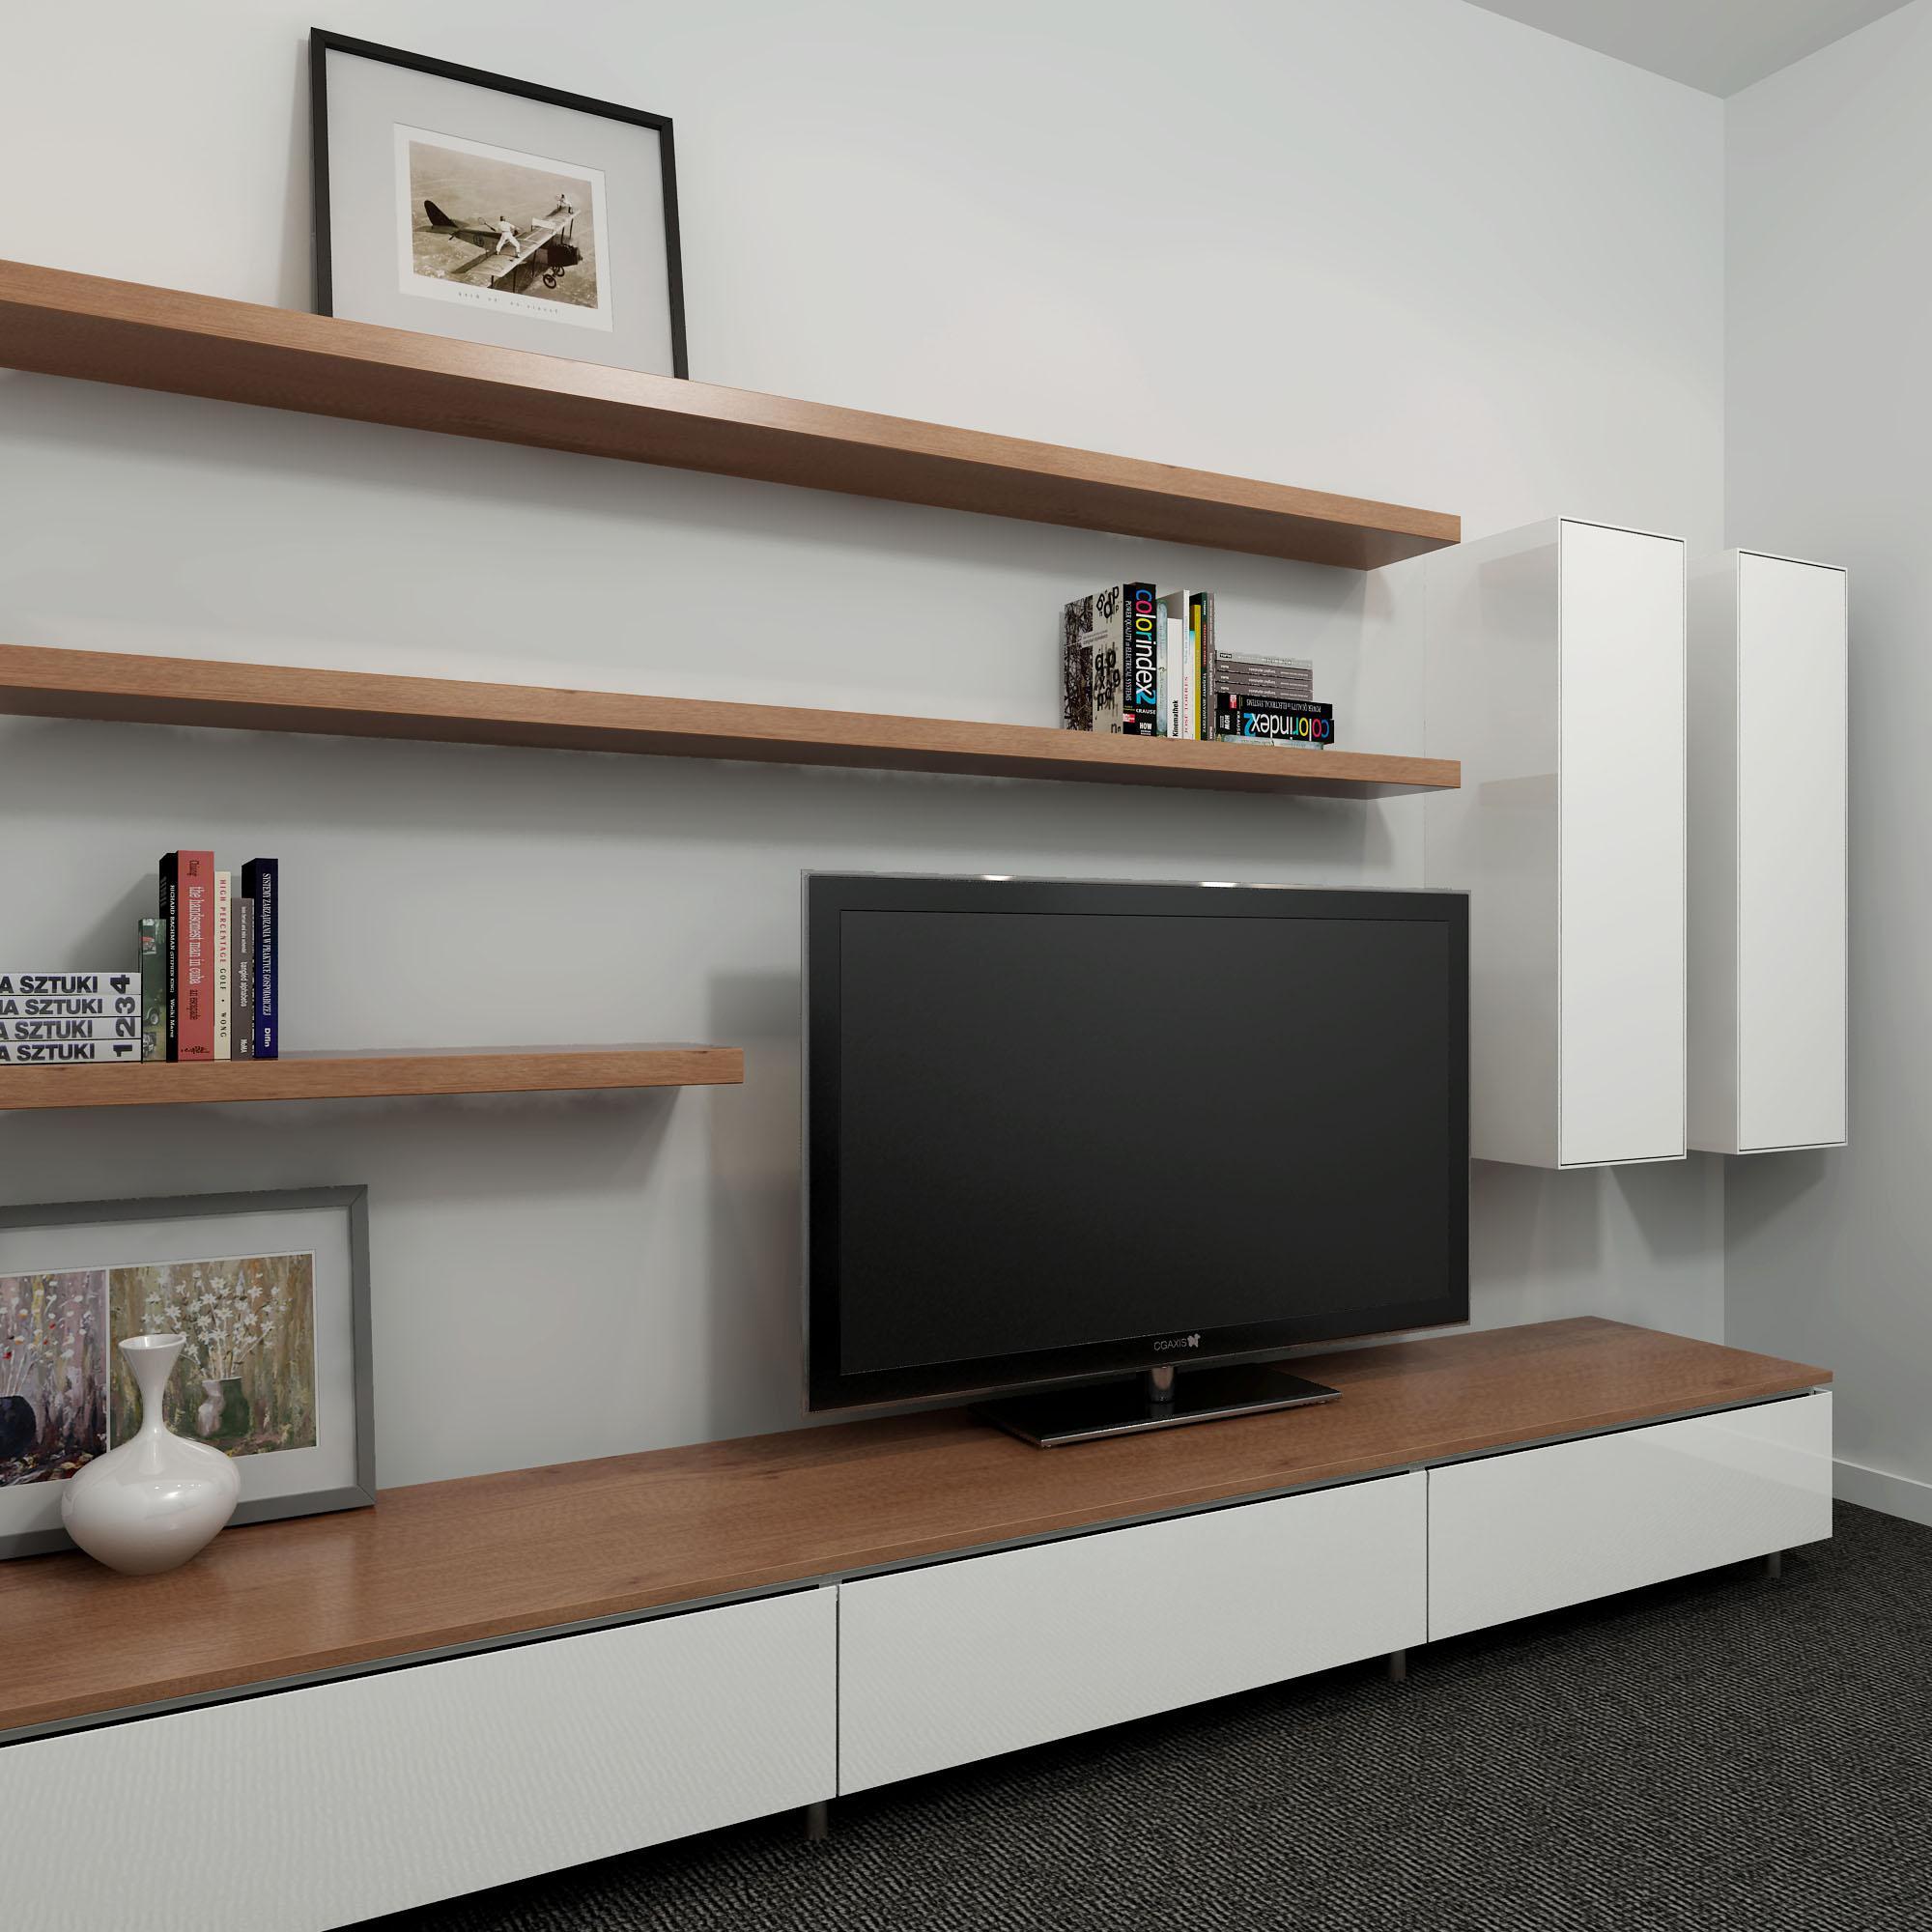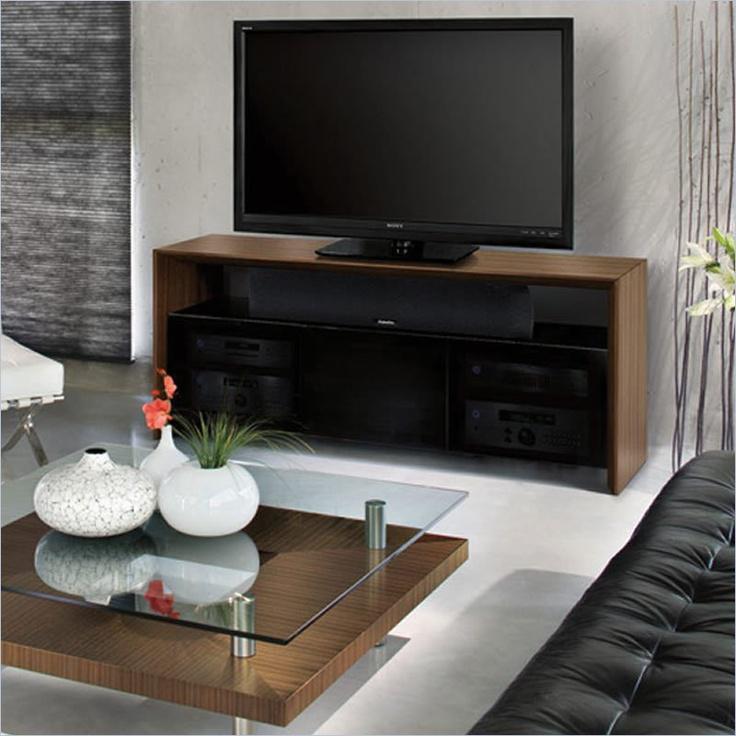The first image is the image on the left, the second image is the image on the right. Evaluate the accuracy of this statement regarding the images: "One picture is sitting on a TV stand next to the TV.". Is it true? Answer yes or no. Yes. 